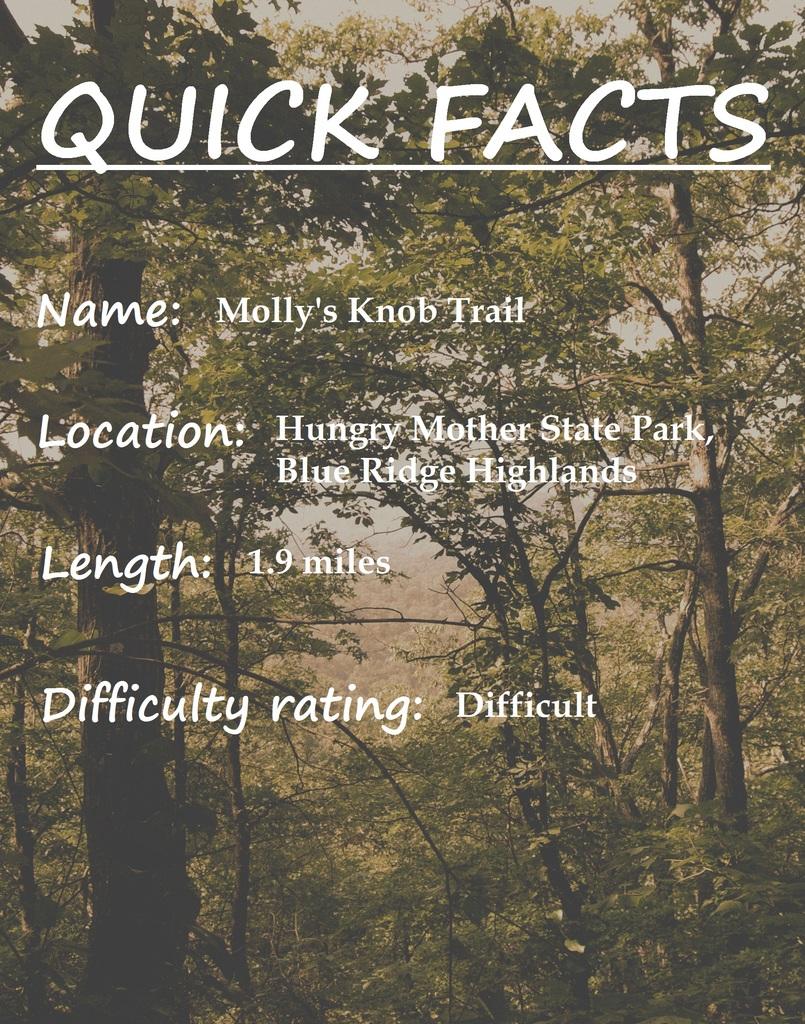What is the name?
Offer a very short reply. Molly's knob trail. 